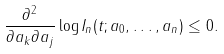<formula> <loc_0><loc_0><loc_500><loc_500>\frac { \partial ^ { 2 } } { \partial a _ { k } \partial a _ { j } } \log I _ { n } ( t ; a _ { 0 } , \dots , a _ { n } ) \leq 0 .</formula> 